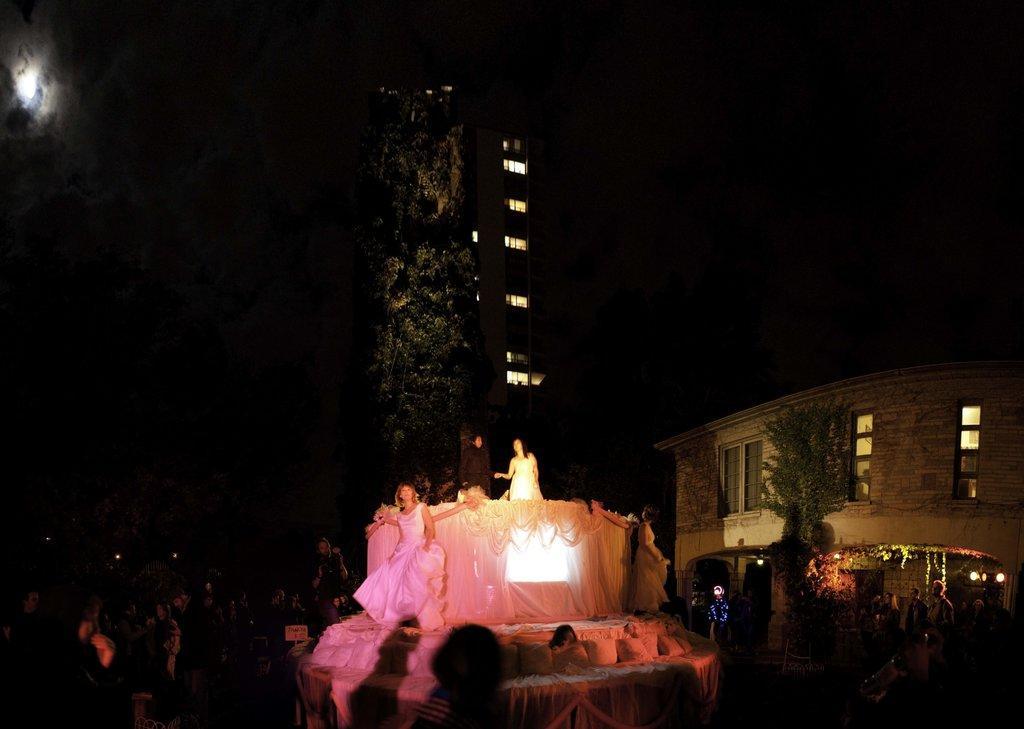Please provide a concise description of this image. Here in this picture in the middle we can see a place is decorated with curtains and lights and we can see two women in white colored dress standing over the place and in front of them we can see number of people standing and watching them and behind them we can see a house with windows present on it and we can also see plants and trees present and beside that we can see a building with windows present and we can see clouds and moon in the sky. 